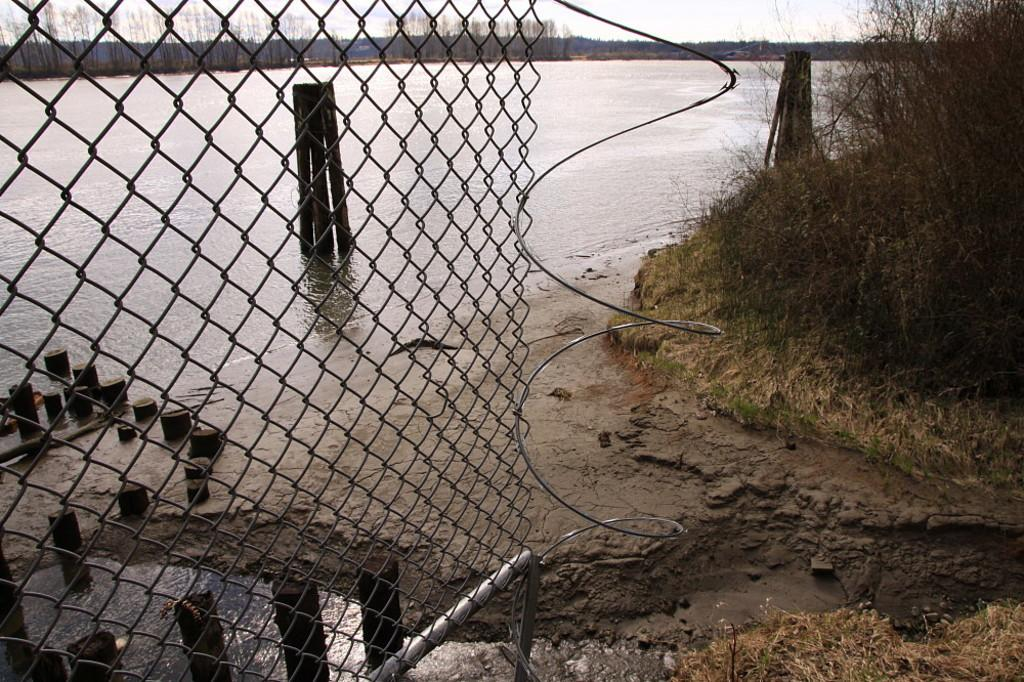What is the primary element present in the picture? There is water in the picture. What type of structure can be seen in the picture? There is a metal fence in the picture. What type of vegetation is visible in the picture? There are trees in the picture. How would you describe the sky in the picture? The sky is cloudy in the picture. How many cats are sitting on the metal fence in the picture? There are no cats present in the picture; it only features water, a metal fence, trees, and a cloudy sky. Is there a fire burning in the picture? There is no fire present in the picture. 